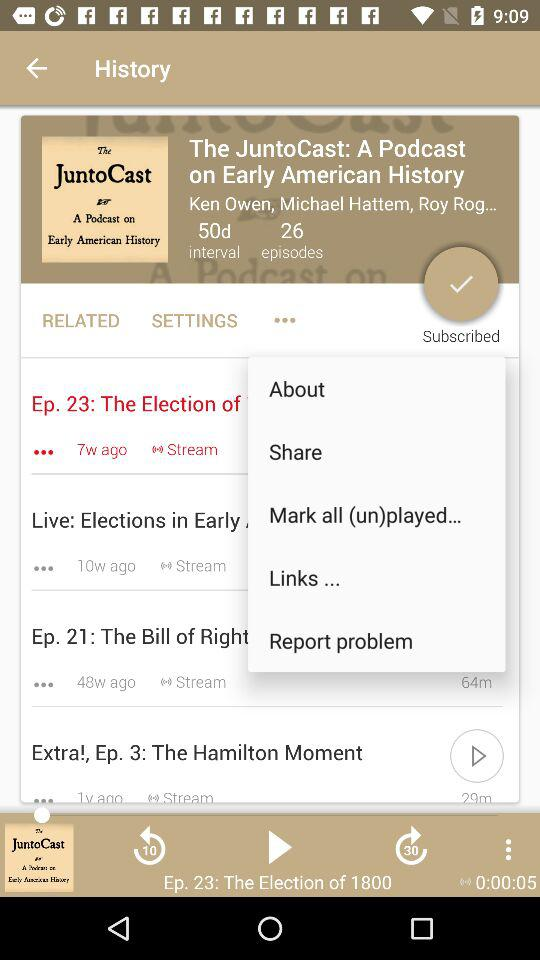How many episodes are older than 10 weeks?
Answer the question using a single word or phrase. 2 